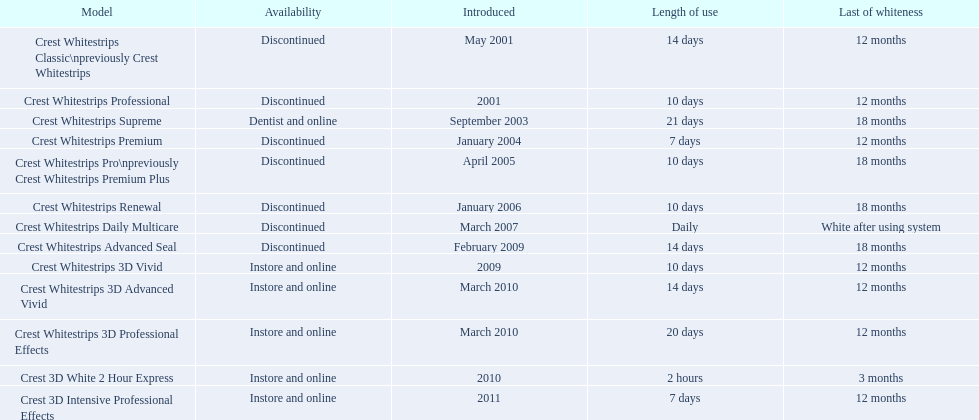What types of crest whitestrips have been released? Crest Whitestrips Classic\npreviously Crest Whitestrips, Crest Whitestrips Professional, Crest Whitestrips Supreme, Crest Whitestrips Premium, Crest Whitestrips Pro\npreviously Crest Whitestrips Premium Plus, Crest Whitestrips Renewal, Crest Whitestrips Daily Multicare, Crest Whitestrips Advanced Seal, Crest Whitestrips 3D Vivid, Crest Whitestrips 3D Advanced Vivid, Crest Whitestrips 3D Professional Effects, Crest 3D White 2 Hour Express, Crest 3D Intensive Professional Effects. What was the length of use for each type? 14 days, 10 days, 21 days, 7 days, 10 days, 10 days, Daily, 14 days, 10 days, 14 days, 20 days, 2 hours, 7 days. And how long did each last? 12 months, 12 months, 18 months, 12 months, 18 months, 18 months, White after using system, 18 months, 12 months, 12 months, 12 months, 3 months, 12 months. Of those models, which lasted the longest with the longest length of use? Crest Whitestrips Supreme. Which of these products are discontinued? Crest Whitestrips Classic\npreviously Crest Whitestrips, Crest Whitestrips Professional, Crest Whitestrips Premium, Crest Whitestrips Pro\npreviously Crest Whitestrips Premium Plus, Crest Whitestrips Renewal, Crest Whitestrips Daily Multicare, Crest Whitestrips Advanced Seal. Which of these products have a 14 day length of use? Crest Whitestrips Classic\npreviously Crest Whitestrips, Crest Whitestrips Advanced Seal. Which of these products was introduced in 2009? Crest Whitestrips Advanced Seal. 